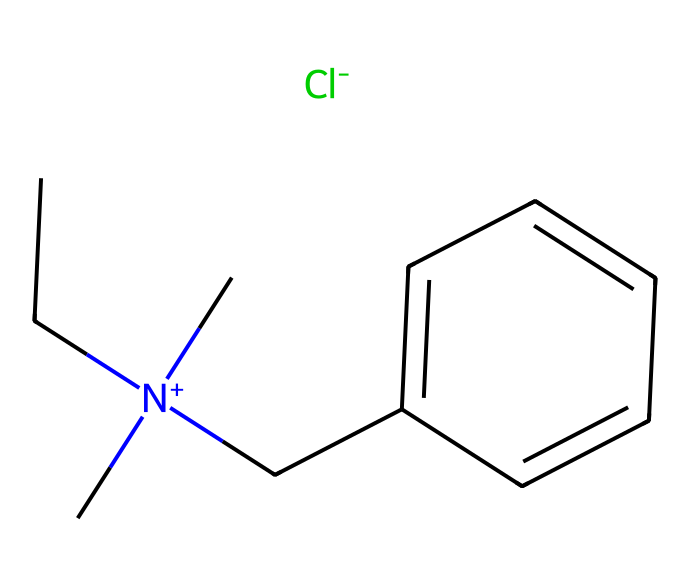What is the main functional group present in benzalkonium chloride? The chemical structure shows a quaternary ammonium group, indicated by the nitrogen atom connected to four substituents, which is characteristic of surfactants.
Answer: quaternary ammonium How many carbon atoms are in benzalkonium chloride? By analyzing the structure, there are 10 carbon atoms (C) in the entire molecule when counting the backbone and side chains.
Answer: 10 What type of ion is present in benzalkonium chloride? The structure contains a chloride ion (Cl-) as indicated by the presence of chlorine in the SMILES representation, which is a hallmark of quaternary ammonium compounds.
Answer: chloride To what class of surfactants does benzalkonium chloride belong? As it has a quaternary nitrogen and a long hydrophobic carbon chain, benzalkonium chloride is classified as a cationic surfactant.
Answer: cationic How many nitrogen atoms are found in the structure of benzalkonium chloride? In the structure, there is one nitrogen atom (N) that is positively charged, contributing to the quaternary ammonium characteristic.
Answer: 1 What is the role of the aromatic ring in the benzalkonium chloride structure? The aromatic ring provides hydrophobic characteristics to the molecule, enhancing its surfactant properties by facilitating interaction with non-polar substances during cleaning and disinfecting.
Answer: hydrophobic properties 